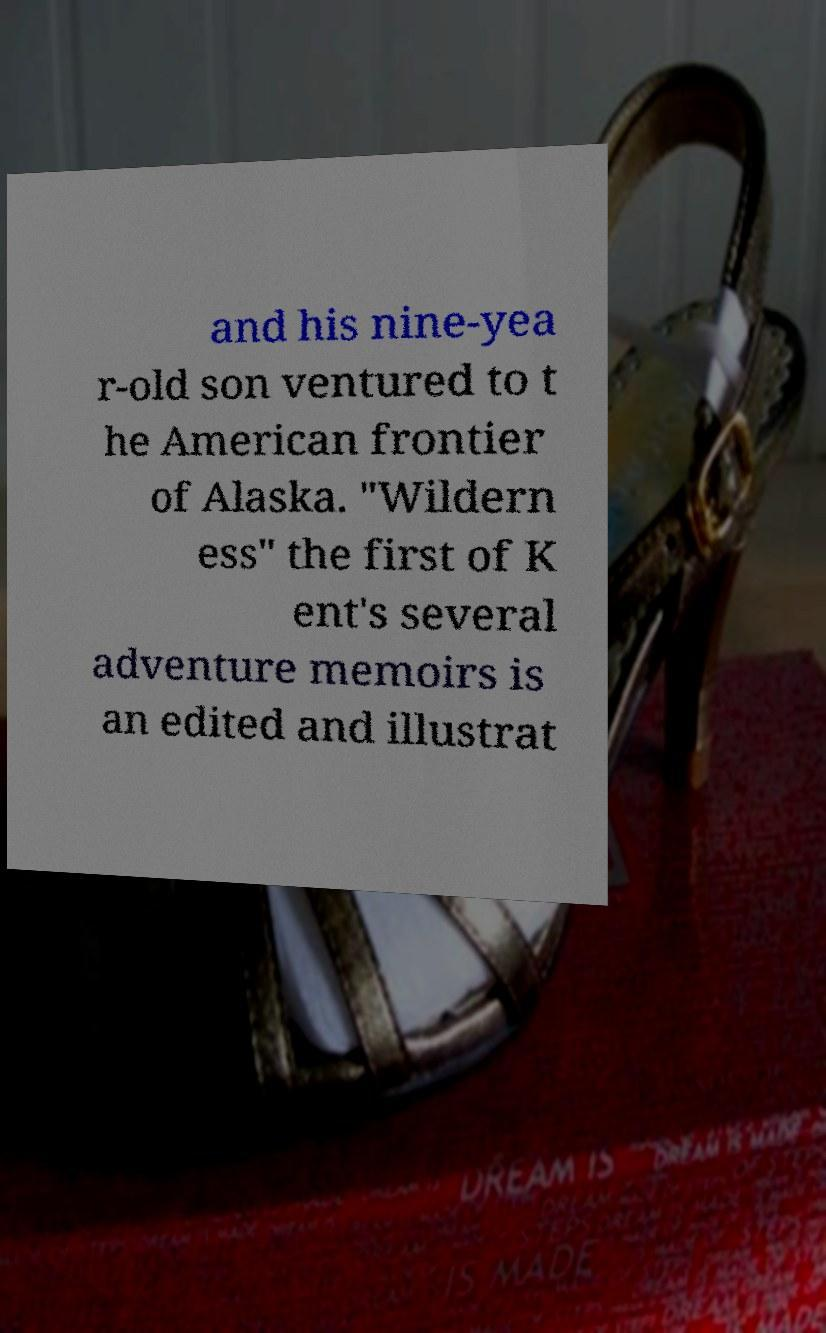For documentation purposes, I need the text within this image transcribed. Could you provide that? and his nine-yea r-old son ventured to t he American frontier of Alaska. "Wildern ess" the first of K ent's several adventure memoirs is an edited and illustrat 